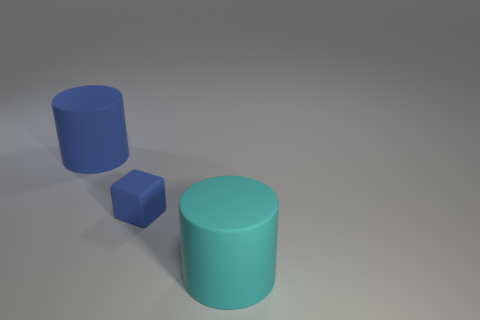Add 3 cubes. How many objects exist? 6 Subtract all cylinders. How many objects are left? 1 Subtract all yellow cylinders. Subtract all red blocks. How many cylinders are left? 2 Subtract all cyan metal cylinders. Subtract all small blocks. How many objects are left? 2 Add 1 blue blocks. How many blue blocks are left? 2 Add 1 small cyan metal balls. How many small cyan metal balls exist? 1 Subtract 0 purple cubes. How many objects are left? 3 